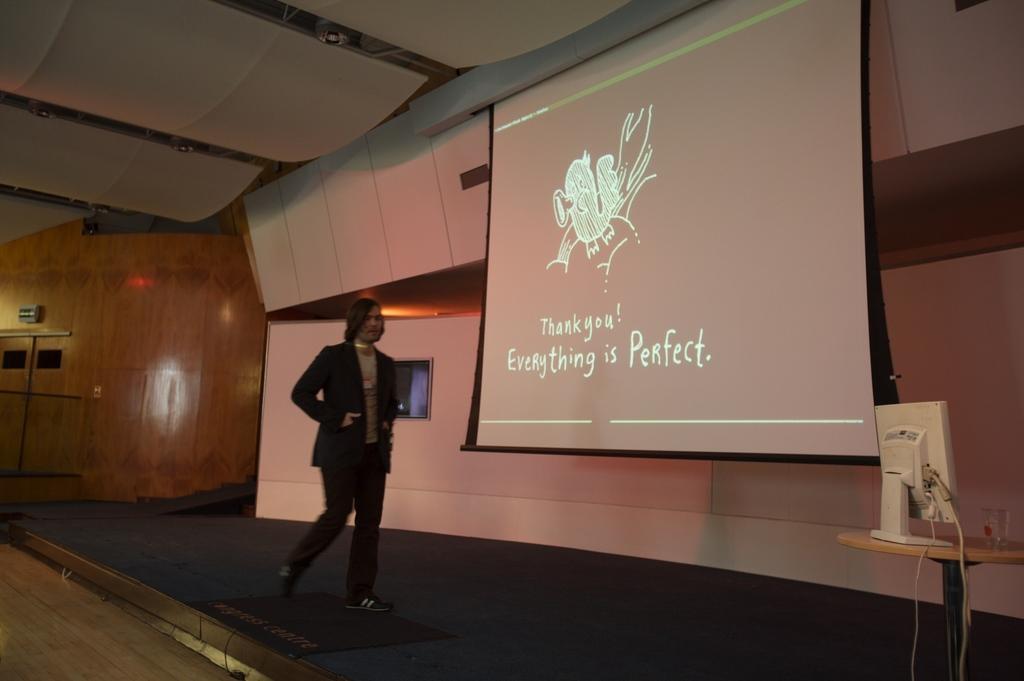In one or two sentences, can you explain what this image depicts? Here is a person wearing black color black walking on to the stage and there is a projector which is showing some presentation , here is a monitor , beside the monitor there is a glass ,there is a table beneath the monitor, behind the projector there are few curtains, in the background there is a wooden wall. 